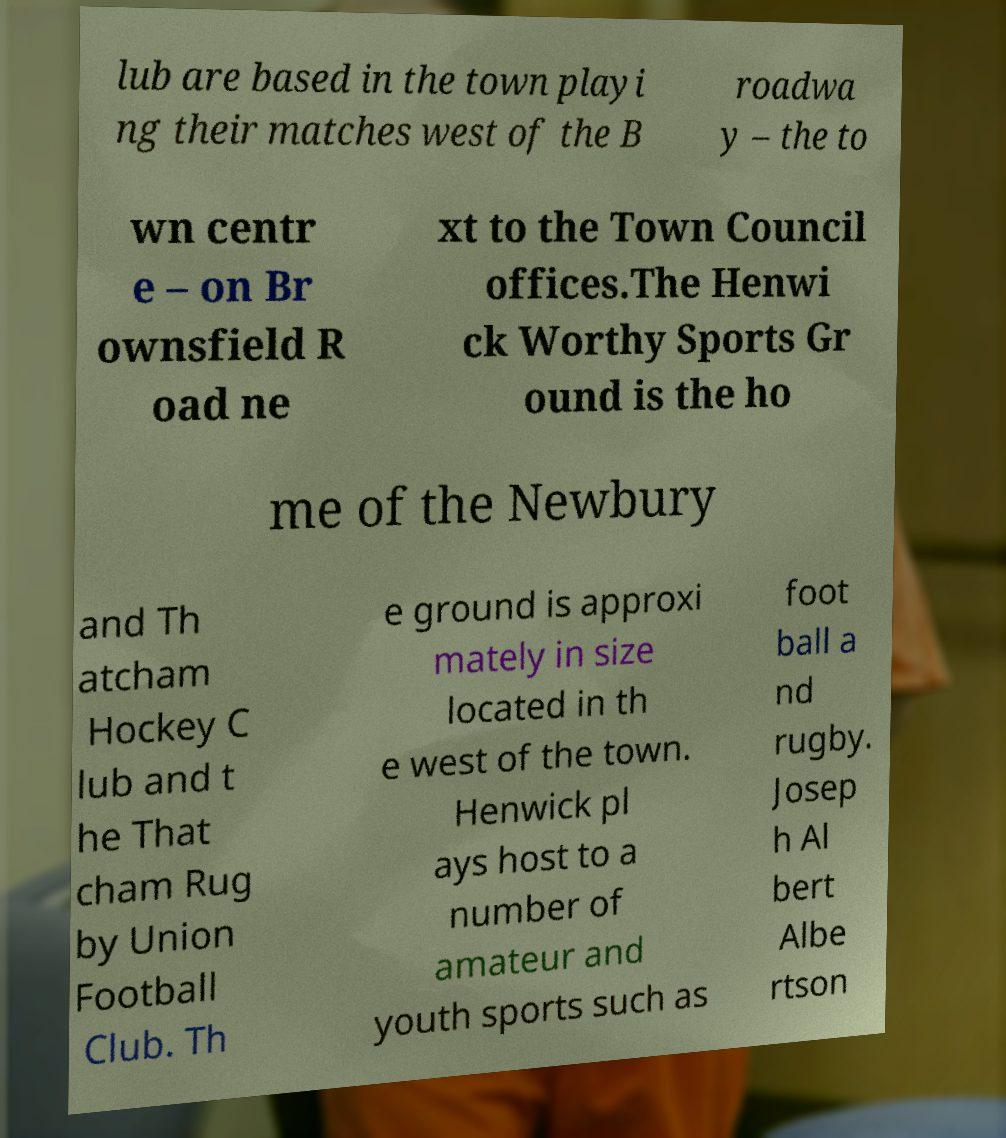Can you read and provide the text displayed in the image?This photo seems to have some interesting text. Can you extract and type it out for me? lub are based in the town playi ng their matches west of the B roadwa y – the to wn centr e – on Br ownsfield R oad ne xt to the Town Council offices.The Henwi ck Worthy Sports Gr ound is the ho me of the Newbury and Th atcham Hockey C lub and t he That cham Rug by Union Football Club. Th e ground is approxi mately in size located in th e west of the town. Henwick pl ays host to a number of amateur and youth sports such as foot ball a nd rugby. Josep h Al bert Albe rtson 